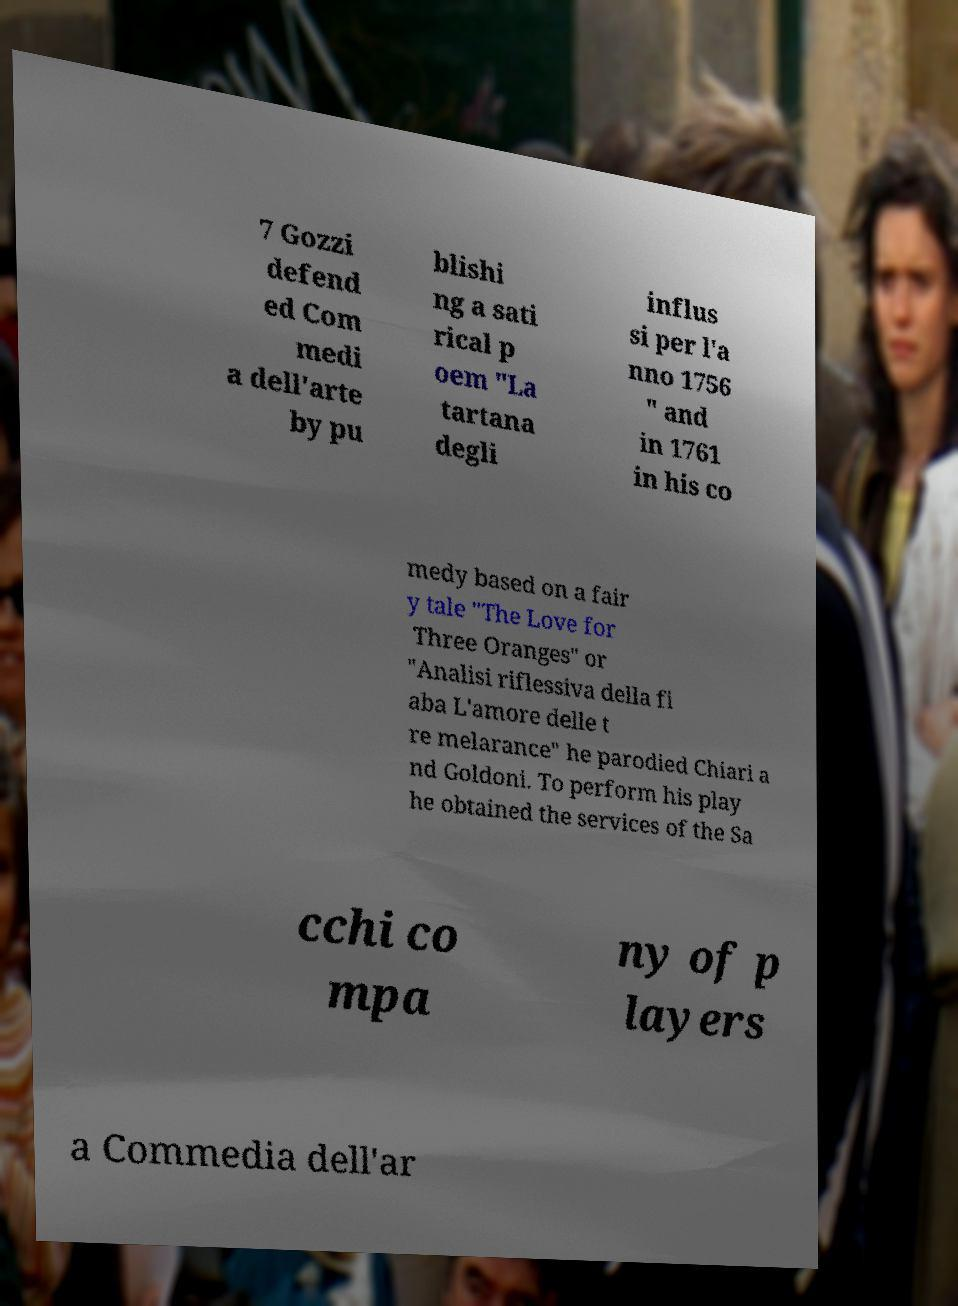Please identify and transcribe the text found in this image. 7 Gozzi defend ed Com medi a dell'arte by pu blishi ng a sati rical p oem "La tartana degli influs si per l'a nno 1756 " and in 1761 in his co medy based on a fair y tale "The Love for Three Oranges" or "Analisi riflessiva della fi aba L'amore delle t re melarance" he parodied Chiari a nd Goldoni. To perform his play he obtained the services of the Sa cchi co mpa ny of p layers a Commedia dell'ar 